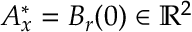Convert formula to latex. <formula><loc_0><loc_0><loc_500><loc_500>A _ { x } ^ { \ast } = B _ { r } ( 0 ) \in \mathbb { R } ^ { 2 }</formula> 